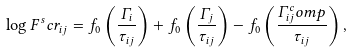<formula> <loc_0><loc_0><loc_500><loc_500>\log F ^ { s } c r _ { i j } = f _ { 0 } \left ( \frac { \Gamma _ { i } } { \tau _ { i j } } \right ) + f _ { 0 } \left ( \frac { \Gamma _ { j } } { \tau _ { i j } } \right ) - f _ { 0 } \left ( \frac { \Gamma _ { i j } ^ { c } o m p } { \tau _ { i j } } \right ) ,</formula> 